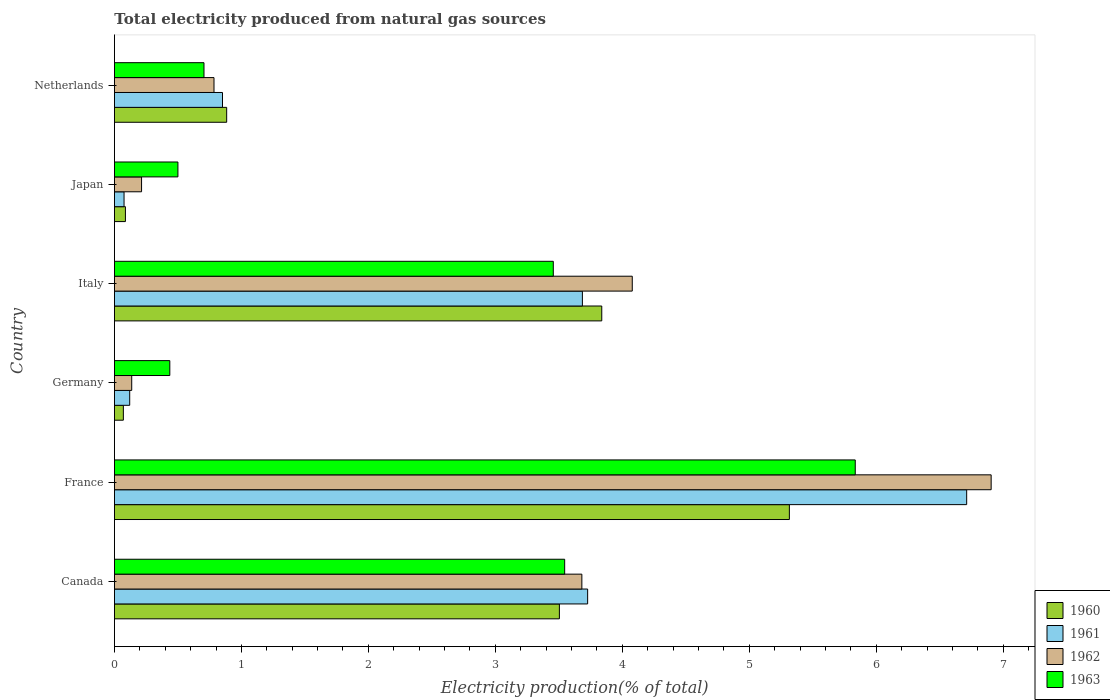How many different coloured bars are there?
Offer a terse response. 4. How many groups of bars are there?
Your response must be concise. 6. How many bars are there on the 4th tick from the bottom?
Give a very brief answer. 4. What is the label of the 4th group of bars from the top?
Ensure brevity in your answer.  Germany. What is the total electricity produced in 1960 in Germany?
Offer a very short reply. 0.07. Across all countries, what is the maximum total electricity produced in 1960?
Offer a terse response. 5.32. Across all countries, what is the minimum total electricity produced in 1961?
Your answer should be compact. 0.08. In which country was the total electricity produced in 1961 maximum?
Your answer should be very brief. France. What is the total total electricity produced in 1963 in the graph?
Give a very brief answer. 14.48. What is the difference between the total electricity produced in 1960 in France and that in Germany?
Keep it short and to the point. 5.25. What is the difference between the total electricity produced in 1961 in France and the total electricity produced in 1960 in Canada?
Your response must be concise. 3.21. What is the average total electricity produced in 1961 per country?
Make the answer very short. 2.53. What is the difference between the total electricity produced in 1962 and total electricity produced in 1963 in Germany?
Ensure brevity in your answer.  -0.3. What is the ratio of the total electricity produced in 1961 in France to that in Japan?
Provide a short and direct response. 88.67. Is the total electricity produced in 1961 in Canada less than that in Germany?
Give a very brief answer. No. What is the difference between the highest and the second highest total electricity produced in 1962?
Your response must be concise. 2.83. What is the difference between the highest and the lowest total electricity produced in 1962?
Offer a very short reply. 6.77. In how many countries, is the total electricity produced in 1961 greater than the average total electricity produced in 1961 taken over all countries?
Ensure brevity in your answer.  3. Is the sum of the total electricity produced in 1960 in Canada and Germany greater than the maximum total electricity produced in 1962 across all countries?
Your response must be concise. No. What does the 4th bar from the top in Japan represents?
Provide a succinct answer. 1960. What does the 1st bar from the bottom in Japan represents?
Ensure brevity in your answer.  1960. Are all the bars in the graph horizontal?
Provide a short and direct response. Yes. How many countries are there in the graph?
Make the answer very short. 6. Does the graph contain any zero values?
Give a very brief answer. No. Does the graph contain grids?
Ensure brevity in your answer.  No. Where does the legend appear in the graph?
Your response must be concise. Bottom right. How many legend labels are there?
Give a very brief answer. 4. How are the legend labels stacked?
Provide a succinct answer. Vertical. What is the title of the graph?
Your answer should be compact. Total electricity produced from natural gas sources. What is the label or title of the X-axis?
Your answer should be very brief. Electricity production(% of total). What is the label or title of the Y-axis?
Make the answer very short. Country. What is the Electricity production(% of total) of 1960 in Canada?
Your answer should be compact. 3.5. What is the Electricity production(% of total) of 1961 in Canada?
Keep it short and to the point. 3.73. What is the Electricity production(% of total) in 1962 in Canada?
Ensure brevity in your answer.  3.68. What is the Electricity production(% of total) of 1963 in Canada?
Give a very brief answer. 3.55. What is the Electricity production(% of total) of 1960 in France?
Offer a very short reply. 5.32. What is the Electricity production(% of total) in 1961 in France?
Your answer should be very brief. 6.71. What is the Electricity production(% of total) in 1962 in France?
Ensure brevity in your answer.  6.91. What is the Electricity production(% of total) of 1963 in France?
Your response must be concise. 5.83. What is the Electricity production(% of total) of 1960 in Germany?
Your response must be concise. 0.07. What is the Electricity production(% of total) in 1961 in Germany?
Provide a short and direct response. 0.12. What is the Electricity production(% of total) of 1962 in Germany?
Provide a succinct answer. 0.14. What is the Electricity production(% of total) in 1963 in Germany?
Your response must be concise. 0.44. What is the Electricity production(% of total) of 1960 in Italy?
Your answer should be very brief. 3.84. What is the Electricity production(% of total) of 1961 in Italy?
Your answer should be very brief. 3.69. What is the Electricity production(% of total) of 1962 in Italy?
Ensure brevity in your answer.  4.08. What is the Electricity production(% of total) of 1963 in Italy?
Offer a very short reply. 3.46. What is the Electricity production(% of total) in 1960 in Japan?
Your answer should be compact. 0.09. What is the Electricity production(% of total) of 1961 in Japan?
Your response must be concise. 0.08. What is the Electricity production(% of total) of 1962 in Japan?
Make the answer very short. 0.21. What is the Electricity production(% of total) in 1963 in Japan?
Provide a short and direct response. 0.5. What is the Electricity production(% of total) in 1960 in Netherlands?
Your response must be concise. 0.88. What is the Electricity production(% of total) in 1961 in Netherlands?
Your answer should be compact. 0.85. What is the Electricity production(% of total) in 1962 in Netherlands?
Your answer should be very brief. 0.78. What is the Electricity production(% of total) of 1963 in Netherlands?
Keep it short and to the point. 0.71. Across all countries, what is the maximum Electricity production(% of total) of 1960?
Your answer should be compact. 5.32. Across all countries, what is the maximum Electricity production(% of total) of 1961?
Offer a terse response. 6.71. Across all countries, what is the maximum Electricity production(% of total) of 1962?
Provide a succinct answer. 6.91. Across all countries, what is the maximum Electricity production(% of total) in 1963?
Ensure brevity in your answer.  5.83. Across all countries, what is the minimum Electricity production(% of total) in 1960?
Provide a short and direct response. 0.07. Across all countries, what is the minimum Electricity production(% of total) in 1961?
Offer a terse response. 0.08. Across all countries, what is the minimum Electricity production(% of total) in 1962?
Keep it short and to the point. 0.14. Across all countries, what is the minimum Electricity production(% of total) in 1963?
Your response must be concise. 0.44. What is the total Electricity production(% of total) of 1960 in the graph?
Offer a very short reply. 13.7. What is the total Electricity production(% of total) in 1961 in the graph?
Your answer should be very brief. 15.17. What is the total Electricity production(% of total) in 1962 in the graph?
Give a very brief answer. 15.8. What is the total Electricity production(% of total) in 1963 in the graph?
Provide a short and direct response. 14.48. What is the difference between the Electricity production(% of total) in 1960 in Canada and that in France?
Give a very brief answer. -1.81. What is the difference between the Electricity production(% of total) of 1961 in Canada and that in France?
Your answer should be compact. -2.99. What is the difference between the Electricity production(% of total) of 1962 in Canada and that in France?
Provide a succinct answer. -3.22. What is the difference between the Electricity production(% of total) in 1963 in Canada and that in France?
Your response must be concise. -2.29. What is the difference between the Electricity production(% of total) in 1960 in Canada and that in Germany?
Offer a very short reply. 3.43. What is the difference between the Electricity production(% of total) in 1961 in Canada and that in Germany?
Your answer should be compact. 3.61. What is the difference between the Electricity production(% of total) in 1962 in Canada and that in Germany?
Ensure brevity in your answer.  3.55. What is the difference between the Electricity production(% of total) of 1963 in Canada and that in Germany?
Your answer should be compact. 3.11. What is the difference between the Electricity production(% of total) in 1960 in Canada and that in Italy?
Give a very brief answer. -0.33. What is the difference between the Electricity production(% of total) of 1961 in Canada and that in Italy?
Give a very brief answer. 0.04. What is the difference between the Electricity production(% of total) in 1962 in Canada and that in Italy?
Your response must be concise. -0.4. What is the difference between the Electricity production(% of total) of 1963 in Canada and that in Italy?
Keep it short and to the point. 0.09. What is the difference between the Electricity production(% of total) in 1960 in Canada and that in Japan?
Keep it short and to the point. 3.42. What is the difference between the Electricity production(% of total) of 1961 in Canada and that in Japan?
Provide a short and direct response. 3.65. What is the difference between the Electricity production(% of total) of 1962 in Canada and that in Japan?
Give a very brief answer. 3.47. What is the difference between the Electricity production(% of total) of 1963 in Canada and that in Japan?
Your answer should be compact. 3.05. What is the difference between the Electricity production(% of total) of 1960 in Canada and that in Netherlands?
Give a very brief answer. 2.62. What is the difference between the Electricity production(% of total) in 1961 in Canada and that in Netherlands?
Offer a very short reply. 2.88. What is the difference between the Electricity production(% of total) in 1962 in Canada and that in Netherlands?
Your response must be concise. 2.9. What is the difference between the Electricity production(% of total) of 1963 in Canada and that in Netherlands?
Keep it short and to the point. 2.84. What is the difference between the Electricity production(% of total) in 1960 in France and that in Germany?
Offer a terse response. 5.25. What is the difference between the Electricity production(% of total) in 1961 in France and that in Germany?
Provide a succinct answer. 6.59. What is the difference between the Electricity production(% of total) in 1962 in France and that in Germany?
Make the answer very short. 6.77. What is the difference between the Electricity production(% of total) of 1963 in France and that in Germany?
Offer a terse response. 5.4. What is the difference between the Electricity production(% of total) of 1960 in France and that in Italy?
Keep it short and to the point. 1.48. What is the difference between the Electricity production(% of total) in 1961 in France and that in Italy?
Offer a terse response. 3.03. What is the difference between the Electricity production(% of total) of 1962 in France and that in Italy?
Provide a succinct answer. 2.83. What is the difference between the Electricity production(% of total) in 1963 in France and that in Italy?
Your answer should be compact. 2.38. What is the difference between the Electricity production(% of total) in 1960 in France and that in Japan?
Provide a short and direct response. 5.23. What is the difference between the Electricity production(% of total) in 1961 in France and that in Japan?
Your response must be concise. 6.64. What is the difference between the Electricity production(% of total) of 1962 in France and that in Japan?
Provide a short and direct response. 6.69. What is the difference between the Electricity production(% of total) of 1963 in France and that in Japan?
Offer a very short reply. 5.33. What is the difference between the Electricity production(% of total) of 1960 in France and that in Netherlands?
Your response must be concise. 4.43. What is the difference between the Electricity production(% of total) of 1961 in France and that in Netherlands?
Make the answer very short. 5.86. What is the difference between the Electricity production(% of total) in 1962 in France and that in Netherlands?
Offer a very short reply. 6.12. What is the difference between the Electricity production(% of total) in 1963 in France and that in Netherlands?
Provide a short and direct response. 5.13. What is the difference between the Electricity production(% of total) in 1960 in Germany and that in Italy?
Give a very brief answer. -3.77. What is the difference between the Electricity production(% of total) in 1961 in Germany and that in Italy?
Your response must be concise. -3.57. What is the difference between the Electricity production(% of total) in 1962 in Germany and that in Italy?
Keep it short and to the point. -3.94. What is the difference between the Electricity production(% of total) of 1963 in Germany and that in Italy?
Your response must be concise. -3.02. What is the difference between the Electricity production(% of total) in 1960 in Germany and that in Japan?
Offer a terse response. -0.02. What is the difference between the Electricity production(% of total) in 1961 in Germany and that in Japan?
Provide a succinct answer. 0.04. What is the difference between the Electricity production(% of total) in 1962 in Germany and that in Japan?
Your answer should be compact. -0.08. What is the difference between the Electricity production(% of total) of 1963 in Germany and that in Japan?
Ensure brevity in your answer.  -0.06. What is the difference between the Electricity production(% of total) in 1960 in Germany and that in Netherlands?
Keep it short and to the point. -0.81. What is the difference between the Electricity production(% of total) of 1961 in Germany and that in Netherlands?
Your response must be concise. -0.73. What is the difference between the Electricity production(% of total) of 1962 in Germany and that in Netherlands?
Your answer should be very brief. -0.65. What is the difference between the Electricity production(% of total) of 1963 in Germany and that in Netherlands?
Offer a very short reply. -0.27. What is the difference between the Electricity production(% of total) of 1960 in Italy and that in Japan?
Provide a short and direct response. 3.75. What is the difference between the Electricity production(% of total) in 1961 in Italy and that in Japan?
Give a very brief answer. 3.61. What is the difference between the Electricity production(% of total) of 1962 in Italy and that in Japan?
Ensure brevity in your answer.  3.86. What is the difference between the Electricity production(% of total) of 1963 in Italy and that in Japan?
Offer a terse response. 2.96. What is the difference between the Electricity production(% of total) in 1960 in Italy and that in Netherlands?
Your answer should be very brief. 2.95. What is the difference between the Electricity production(% of total) of 1961 in Italy and that in Netherlands?
Give a very brief answer. 2.83. What is the difference between the Electricity production(% of total) in 1962 in Italy and that in Netherlands?
Offer a very short reply. 3.29. What is the difference between the Electricity production(% of total) in 1963 in Italy and that in Netherlands?
Provide a short and direct response. 2.75. What is the difference between the Electricity production(% of total) in 1960 in Japan and that in Netherlands?
Ensure brevity in your answer.  -0.8. What is the difference between the Electricity production(% of total) in 1961 in Japan and that in Netherlands?
Provide a short and direct response. -0.78. What is the difference between the Electricity production(% of total) of 1962 in Japan and that in Netherlands?
Give a very brief answer. -0.57. What is the difference between the Electricity production(% of total) of 1963 in Japan and that in Netherlands?
Your answer should be very brief. -0.21. What is the difference between the Electricity production(% of total) in 1960 in Canada and the Electricity production(% of total) in 1961 in France?
Ensure brevity in your answer.  -3.21. What is the difference between the Electricity production(% of total) in 1960 in Canada and the Electricity production(% of total) in 1962 in France?
Ensure brevity in your answer.  -3.4. What is the difference between the Electricity production(% of total) of 1960 in Canada and the Electricity production(% of total) of 1963 in France?
Provide a short and direct response. -2.33. What is the difference between the Electricity production(% of total) of 1961 in Canada and the Electricity production(% of total) of 1962 in France?
Your answer should be compact. -3.18. What is the difference between the Electricity production(% of total) in 1961 in Canada and the Electricity production(% of total) in 1963 in France?
Offer a terse response. -2.11. What is the difference between the Electricity production(% of total) of 1962 in Canada and the Electricity production(% of total) of 1963 in France?
Offer a terse response. -2.15. What is the difference between the Electricity production(% of total) in 1960 in Canada and the Electricity production(% of total) in 1961 in Germany?
Give a very brief answer. 3.38. What is the difference between the Electricity production(% of total) of 1960 in Canada and the Electricity production(% of total) of 1962 in Germany?
Provide a short and direct response. 3.37. What is the difference between the Electricity production(% of total) in 1960 in Canada and the Electricity production(% of total) in 1963 in Germany?
Provide a short and direct response. 3.07. What is the difference between the Electricity production(% of total) in 1961 in Canada and the Electricity production(% of total) in 1962 in Germany?
Give a very brief answer. 3.59. What is the difference between the Electricity production(% of total) in 1961 in Canada and the Electricity production(% of total) in 1963 in Germany?
Your answer should be compact. 3.29. What is the difference between the Electricity production(% of total) in 1962 in Canada and the Electricity production(% of total) in 1963 in Germany?
Offer a terse response. 3.25. What is the difference between the Electricity production(% of total) of 1960 in Canada and the Electricity production(% of total) of 1961 in Italy?
Provide a short and direct response. -0.18. What is the difference between the Electricity production(% of total) in 1960 in Canada and the Electricity production(% of total) in 1962 in Italy?
Your response must be concise. -0.57. What is the difference between the Electricity production(% of total) in 1960 in Canada and the Electricity production(% of total) in 1963 in Italy?
Give a very brief answer. 0.05. What is the difference between the Electricity production(% of total) in 1961 in Canada and the Electricity production(% of total) in 1962 in Italy?
Offer a very short reply. -0.35. What is the difference between the Electricity production(% of total) in 1961 in Canada and the Electricity production(% of total) in 1963 in Italy?
Offer a very short reply. 0.27. What is the difference between the Electricity production(% of total) in 1962 in Canada and the Electricity production(% of total) in 1963 in Italy?
Provide a short and direct response. 0.23. What is the difference between the Electricity production(% of total) in 1960 in Canada and the Electricity production(% of total) in 1961 in Japan?
Give a very brief answer. 3.43. What is the difference between the Electricity production(% of total) of 1960 in Canada and the Electricity production(% of total) of 1962 in Japan?
Offer a terse response. 3.29. What is the difference between the Electricity production(% of total) of 1960 in Canada and the Electricity production(% of total) of 1963 in Japan?
Ensure brevity in your answer.  3. What is the difference between the Electricity production(% of total) of 1961 in Canada and the Electricity production(% of total) of 1962 in Japan?
Give a very brief answer. 3.51. What is the difference between the Electricity production(% of total) of 1961 in Canada and the Electricity production(% of total) of 1963 in Japan?
Offer a terse response. 3.23. What is the difference between the Electricity production(% of total) in 1962 in Canada and the Electricity production(% of total) in 1963 in Japan?
Offer a terse response. 3.18. What is the difference between the Electricity production(% of total) of 1960 in Canada and the Electricity production(% of total) of 1961 in Netherlands?
Your answer should be very brief. 2.65. What is the difference between the Electricity production(% of total) in 1960 in Canada and the Electricity production(% of total) in 1962 in Netherlands?
Keep it short and to the point. 2.72. What is the difference between the Electricity production(% of total) of 1960 in Canada and the Electricity production(% of total) of 1963 in Netherlands?
Your answer should be very brief. 2.8. What is the difference between the Electricity production(% of total) of 1961 in Canada and the Electricity production(% of total) of 1962 in Netherlands?
Your response must be concise. 2.94. What is the difference between the Electricity production(% of total) in 1961 in Canada and the Electricity production(% of total) in 1963 in Netherlands?
Your answer should be compact. 3.02. What is the difference between the Electricity production(% of total) in 1962 in Canada and the Electricity production(% of total) in 1963 in Netherlands?
Make the answer very short. 2.98. What is the difference between the Electricity production(% of total) of 1960 in France and the Electricity production(% of total) of 1961 in Germany?
Provide a succinct answer. 5.2. What is the difference between the Electricity production(% of total) of 1960 in France and the Electricity production(% of total) of 1962 in Germany?
Your response must be concise. 5.18. What is the difference between the Electricity production(% of total) in 1960 in France and the Electricity production(% of total) in 1963 in Germany?
Ensure brevity in your answer.  4.88. What is the difference between the Electricity production(% of total) of 1961 in France and the Electricity production(% of total) of 1962 in Germany?
Ensure brevity in your answer.  6.58. What is the difference between the Electricity production(% of total) of 1961 in France and the Electricity production(% of total) of 1963 in Germany?
Offer a very short reply. 6.28. What is the difference between the Electricity production(% of total) of 1962 in France and the Electricity production(% of total) of 1963 in Germany?
Give a very brief answer. 6.47. What is the difference between the Electricity production(% of total) in 1960 in France and the Electricity production(% of total) in 1961 in Italy?
Offer a very short reply. 1.63. What is the difference between the Electricity production(% of total) of 1960 in France and the Electricity production(% of total) of 1962 in Italy?
Give a very brief answer. 1.24. What is the difference between the Electricity production(% of total) in 1960 in France and the Electricity production(% of total) in 1963 in Italy?
Keep it short and to the point. 1.86. What is the difference between the Electricity production(% of total) in 1961 in France and the Electricity production(% of total) in 1962 in Italy?
Ensure brevity in your answer.  2.63. What is the difference between the Electricity production(% of total) of 1961 in France and the Electricity production(% of total) of 1963 in Italy?
Ensure brevity in your answer.  3.26. What is the difference between the Electricity production(% of total) in 1962 in France and the Electricity production(% of total) in 1963 in Italy?
Make the answer very short. 3.45. What is the difference between the Electricity production(% of total) of 1960 in France and the Electricity production(% of total) of 1961 in Japan?
Offer a very short reply. 5.24. What is the difference between the Electricity production(% of total) in 1960 in France and the Electricity production(% of total) in 1962 in Japan?
Offer a terse response. 5.1. What is the difference between the Electricity production(% of total) in 1960 in France and the Electricity production(% of total) in 1963 in Japan?
Provide a short and direct response. 4.82. What is the difference between the Electricity production(% of total) of 1961 in France and the Electricity production(% of total) of 1962 in Japan?
Provide a short and direct response. 6.5. What is the difference between the Electricity production(% of total) in 1961 in France and the Electricity production(% of total) in 1963 in Japan?
Provide a succinct answer. 6.21. What is the difference between the Electricity production(% of total) in 1962 in France and the Electricity production(% of total) in 1963 in Japan?
Keep it short and to the point. 6.4. What is the difference between the Electricity production(% of total) in 1960 in France and the Electricity production(% of total) in 1961 in Netherlands?
Your answer should be compact. 4.46. What is the difference between the Electricity production(% of total) in 1960 in France and the Electricity production(% of total) in 1962 in Netherlands?
Make the answer very short. 4.53. What is the difference between the Electricity production(% of total) in 1960 in France and the Electricity production(% of total) in 1963 in Netherlands?
Your answer should be very brief. 4.61. What is the difference between the Electricity production(% of total) of 1961 in France and the Electricity production(% of total) of 1962 in Netherlands?
Keep it short and to the point. 5.93. What is the difference between the Electricity production(% of total) of 1961 in France and the Electricity production(% of total) of 1963 in Netherlands?
Ensure brevity in your answer.  6.01. What is the difference between the Electricity production(% of total) in 1962 in France and the Electricity production(% of total) in 1963 in Netherlands?
Give a very brief answer. 6.2. What is the difference between the Electricity production(% of total) in 1960 in Germany and the Electricity production(% of total) in 1961 in Italy?
Your answer should be compact. -3.62. What is the difference between the Electricity production(% of total) of 1960 in Germany and the Electricity production(% of total) of 1962 in Italy?
Offer a terse response. -4.01. What is the difference between the Electricity production(% of total) in 1960 in Germany and the Electricity production(% of total) in 1963 in Italy?
Your answer should be very brief. -3.39. What is the difference between the Electricity production(% of total) in 1961 in Germany and the Electricity production(% of total) in 1962 in Italy?
Your response must be concise. -3.96. What is the difference between the Electricity production(% of total) of 1961 in Germany and the Electricity production(% of total) of 1963 in Italy?
Keep it short and to the point. -3.34. What is the difference between the Electricity production(% of total) of 1962 in Germany and the Electricity production(% of total) of 1963 in Italy?
Your response must be concise. -3.32. What is the difference between the Electricity production(% of total) in 1960 in Germany and the Electricity production(% of total) in 1961 in Japan?
Ensure brevity in your answer.  -0.01. What is the difference between the Electricity production(% of total) in 1960 in Germany and the Electricity production(% of total) in 1962 in Japan?
Ensure brevity in your answer.  -0.14. What is the difference between the Electricity production(% of total) of 1960 in Germany and the Electricity production(% of total) of 1963 in Japan?
Make the answer very short. -0.43. What is the difference between the Electricity production(% of total) of 1961 in Germany and the Electricity production(% of total) of 1962 in Japan?
Offer a terse response. -0.09. What is the difference between the Electricity production(% of total) of 1961 in Germany and the Electricity production(% of total) of 1963 in Japan?
Offer a very short reply. -0.38. What is the difference between the Electricity production(% of total) of 1962 in Germany and the Electricity production(% of total) of 1963 in Japan?
Your answer should be very brief. -0.36. What is the difference between the Electricity production(% of total) of 1960 in Germany and the Electricity production(% of total) of 1961 in Netherlands?
Keep it short and to the point. -0.78. What is the difference between the Electricity production(% of total) in 1960 in Germany and the Electricity production(% of total) in 1962 in Netherlands?
Offer a terse response. -0.71. What is the difference between the Electricity production(% of total) of 1960 in Germany and the Electricity production(% of total) of 1963 in Netherlands?
Ensure brevity in your answer.  -0.64. What is the difference between the Electricity production(% of total) in 1961 in Germany and the Electricity production(% of total) in 1962 in Netherlands?
Your answer should be compact. -0.66. What is the difference between the Electricity production(% of total) of 1961 in Germany and the Electricity production(% of total) of 1963 in Netherlands?
Offer a very short reply. -0.58. What is the difference between the Electricity production(% of total) of 1962 in Germany and the Electricity production(% of total) of 1963 in Netherlands?
Give a very brief answer. -0.57. What is the difference between the Electricity production(% of total) of 1960 in Italy and the Electricity production(% of total) of 1961 in Japan?
Your response must be concise. 3.76. What is the difference between the Electricity production(% of total) of 1960 in Italy and the Electricity production(% of total) of 1962 in Japan?
Ensure brevity in your answer.  3.62. What is the difference between the Electricity production(% of total) of 1960 in Italy and the Electricity production(% of total) of 1963 in Japan?
Provide a short and direct response. 3.34. What is the difference between the Electricity production(% of total) of 1961 in Italy and the Electricity production(% of total) of 1962 in Japan?
Keep it short and to the point. 3.47. What is the difference between the Electricity production(% of total) of 1961 in Italy and the Electricity production(% of total) of 1963 in Japan?
Ensure brevity in your answer.  3.19. What is the difference between the Electricity production(% of total) in 1962 in Italy and the Electricity production(% of total) in 1963 in Japan?
Ensure brevity in your answer.  3.58. What is the difference between the Electricity production(% of total) of 1960 in Italy and the Electricity production(% of total) of 1961 in Netherlands?
Offer a very short reply. 2.99. What is the difference between the Electricity production(% of total) of 1960 in Italy and the Electricity production(% of total) of 1962 in Netherlands?
Keep it short and to the point. 3.05. What is the difference between the Electricity production(% of total) in 1960 in Italy and the Electricity production(% of total) in 1963 in Netherlands?
Provide a short and direct response. 3.13. What is the difference between the Electricity production(% of total) in 1961 in Italy and the Electricity production(% of total) in 1962 in Netherlands?
Your answer should be very brief. 2.9. What is the difference between the Electricity production(% of total) of 1961 in Italy and the Electricity production(% of total) of 1963 in Netherlands?
Give a very brief answer. 2.98. What is the difference between the Electricity production(% of total) of 1962 in Italy and the Electricity production(% of total) of 1963 in Netherlands?
Your answer should be very brief. 3.37. What is the difference between the Electricity production(% of total) of 1960 in Japan and the Electricity production(% of total) of 1961 in Netherlands?
Give a very brief answer. -0.76. What is the difference between the Electricity production(% of total) of 1960 in Japan and the Electricity production(% of total) of 1962 in Netherlands?
Provide a short and direct response. -0.7. What is the difference between the Electricity production(% of total) of 1960 in Japan and the Electricity production(% of total) of 1963 in Netherlands?
Offer a terse response. -0.62. What is the difference between the Electricity production(% of total) of 1961 in Japan and the Electricity production(% of total) of 1962 in Netherlands?
Give a very brief answer. -0.71. What is the difference between the Electricity production(% of total) in 1961 in Japan and the Electricity production(% of total) in 1963 in Netherlands?
Your answer should be very brief. -0.63. What is the difference between the Electricity production(% of total) of 1962 in Japan and the Electricity production(% of total) of 1963 in Netherlands?
Your answer should be very brief. -0.49. What is the average Electricity production(% of total) in 1960 per country?
Keep it short and to the point. 2.28. What is the average Electricity production(% of total) in 1961 per country?
Make the answer very short. 2.53. What is the average Electricity production(% of total) in 1962 per country?
Keep it short and to the point. 2.63. What is the average Electricity production(% of total) of 1963 per country?
Offer a terse response. 2.41. What is the difference between the Electricity production(% of total) in 1960 and Electricity production(% of total) in 1961 in Canada?
Make the answer very short. -0.22. What is the difference between the Electricity production(% of total) in 1960 and Electricity production(% of total) in 1962 in Canada?
Offer a very short reply. -0.18. What is the difference between the Electricity production(% of total) in 1960 and Electricity production(% of total) in 1963 in Canada?
Give a very brief answer. -0.04. What is the difference between the Electricity production(% of total) of 1961 and Electricity production(% of total) of 1962 in Canada?
Your answer should be compact. 0.05. What is the difference between the Electricity production(% of total) in 1961 and Electricity production(% of total) in 1963 in Canada?
Ensure brevity in your answer.  0.18. What is the difference between the Electricity production(% of total) in 1962 and Electricity production(% of total) in 1963 in Canada?
Your answer should be very brief. 0.14. What is the difference between the Electricity production(% of total) in 1960 and Electricity production(% of total) in 1961 in France?
Provide a short and direct response. -1.4. What is the difference between the Electricity production(% of total) of 1960 and Electricity production(% of total) of 1962 in France?
Your answer should be compact. -1.59. What is the difference between the Electricity production(% of total) of 1960 and Electricity production(% of total) of 1963 in France?
Your answer should be very brief. -0.52. What is the difference between the Electricity production(% of total) in 1961 and Electricity production(% of total) in 1962 in France?
Offer a very short reply. -0.19. What is the difference between the Electricity production(% of total) of 1961 and Electricity production(% of total) of 1963 in France?
Provide a succinct answer. 0.88. What is the difference between the Electricity production(% of total) in 1962 and Electricity production(% of total) in 1963 in France?
Ensure brevity in your answer.  1.07. What is the difference between the Electricity production(% of total) in 1960 and Electricity production(% of total) in 1962 in Germany?
Provide a short and direct response. -0.07. What is the difference between the Electricity production(% of total) of 1960 and Electricity production(% of total) of 1963 in Germany?
Offer a very short reply. -0.37. What is the difference between the Electricity production(% of total) in 1961 and Electricity production(% of total) in 1962 in Germany?
Keep it short and to the point. -0.02. What is the difference between the Electricity production(% of total) in 1961 and Electricity production(% of total) in 1963 in Germany?
Keep it short and to the point. -0.32. What is the difference between the Electricity production(% of total) in 1962 and Electricity production(% of total) in 1963 in Germany?
Make the answer very short. -0.3. What is the difference between the Electricity production(% of total) in 1960 and Electricity production(% of total) in 1961 in Italy?
Your response must be concise. 0.15. What is the difference between the Electricity production(% of total) of 1960 and Electricity production(% of total) of 1962 in Italy?
Offer a terse response. -0.24. What is the difference between the Electricity production(% of total) in 1960 and Electricity production(% of total) in 1963 in Italy?
Ensure brevity in your answer.  0.38. What is the difference between the Electricity production(% of total) of 1961 and Electricity production(% of total) of 1962 in Italy?
Your answer should be compact. -0.39. What is the difference between the Electricity production(% of total) in 1961 and Electricity production(% of total) in 1963 in Italy?
Your response must be concise. 0.23. What is the difference between the Electricity production(% of total) in 1962 and Electricity production(% of total) in 1963 in Italy?
Make the answer very short. 0.62. What is the difference between the Electricity production(% of total) of 1960 and Electricity production(% of total) of 1961 in Japan?
Your response must be concise. 0.01. What is the difference between the Electricity production(% of total) of 1960 and Electricity production(% of total) of 1962 in Japan?
Offer a terse response. -0.13. What is the difference between the Electricity production(% of total) of 1960 and Electricity production(% of total) of 1963 in Japan?
Ensure brevity in your answer.  -0.41. What is the difference between the Electricity production(% of total) of 1961 and Electricity production(% of total) of 1962 in Japan?
Provide a succinct answer. -0.14. What is the difference between the Electricity production(% of total) in 1961 and Electricity production(% of total) in 1963 in Japan?
Keep it short and to the point. -0.42. What is the difference between the Electricity production(% of total) of 1962 and Electricity production(% of total) of 1963 in Japan?
Offer a very short reply. -0.29. What is the difference between the Electricity production(% of total) of 1960 and Electricity production(% of total) of 1961 in Netherlands?
Provide a succinct answer. 0.03. What is the difference between the Electricity production(% of total) in 1960 and Electricity production(% of total) in 1962 in Netherlands?
Make the answer very short. 0.1. What is the difference between the Electricity production(% of total) in 1960 and Electricity production(% of total) in 1963 in Netherlands?
Provide a short and direct response. 0.18. What is the difference between the Electricity production(% of total) in 1961 and Electricity production(% of total) in 1962 in Netherlands?
Offer a terse response. 0.07. What is the difference between the Electricity production(% of total) of 1961 and Electricity production(% of total) of 1963 in Netherlands?
Provide a short and direct response. 0.15. What is the difference between the Electricity production(% of total) of 1962 and Electricity production(% of total) of 1963 in Netherlands?
Keep it short and to the point. 0.08. What is the ratio of the Electricity production(% of total) in 1960 in Canada to that in France?
Offer a very short reply. 0.66. What is the ratio of the Electricity production(% of total) of 1961 in Canada to that in France?
Your answer should be compact. 0.56. What is the ratio of the Electricity production(% of total) in 1962 in Canada to that in France?
Provide a short and direct response. 0.53. What is the ratio of the Electricity production(% of total) in 1963 in Canada to that in France?
Provide a succinct answer. 0.61. What is the ratio of the Electricity production(% of total) in 1960 in Canada to that in Germany?
Make the answer very short. 49.85. What is the ratio of the Electricity production(% of total) of 1961 in Canada to that in Germany?
Provide a short and direct response. 30.98. What is the ratio of the Electricity production(% of total) of 1962 in Canada to that in Germany?
Make the answer very short. 27.02. What is the ratio of the Electricity production(% of total) of 1963 in Canada to that in Germany?
Offer a very short reply. 8.13. What is the ratio of the Electricity production(% of total) in 1960 in Canada to that in Italy?
Offer a very short reply. 0.91. What is the ratio of the Electricity production(% of total) in 1961 in Canada to that in Italy?
Provide a succinct answer. 1.01. What is the ratio of the Electricity production(% of total) in 1962 in Canada to that in Italy?
Your response must be concise. 0.9. What is the ratio of the Electricity production(% of total) of 1963 in Canada to that in Italy?
Your answer should be very brief. 1.03. What is the ratio of the Electricity production(% of total) in 1960 in Canada to that in Japan?
Keep it short and to the point. 40.48. What is the ratio of the Electricity production(% of total) in 1961 in Canada to that in Japan?
Keep it short and to the point. 49.23. What is the ratio of the Electricity production(% of total) of 1962 in Canada to that in Japan?
Offer a terse response. 17.23. What is the ratio of the Electricity production(% of total) of 1963 in Canada to that in Japan?
Keep it short and to the point. 7.09. What is the ratio of the Electricity production(% of total) of 1960 in Canada to that in Netherlands?
Offer a terse response. 3.96. What is the ratio of the Electricity production(% of total) in 1961 in Canada to that in Netherlands?
Your answer should be very brief. 4.38. What is the ratio of the Electricity production(% of total) of 1962 in Canada to that in Netherlands?
Your answer should be very brief. 4.69. What is the ratio of the Electricity production(% of total) in 1963 in Canada to that in Netherlands?
Your answer should be compact. 5.03. What is the ratio of the Electricity production(% of total) of 1960 in France to that in Germany?
Provide a short and direct response. 75.62. What is the ratio of the Electricity production(% of total) of 1961 in France to that in Germany?
Make the answer very short. 55.79. What is the ratio of the Electricity production(% of total) of 1962 in France to that in Germany?
Provide a succinct answer. 50.69. What is the ratio of the Electricity production(% of total) in 1963 in France to that in Germany?
Provide a succinct answer. 13.38. What is the ratio of the Electricity production(% of total) of 1960 in France to that in Italy?
Offer a very short reply. 1.39. What is the ratio of the Electricity production(% of total) of 1961 in France to that in Italy?
Keep it short and to the point. 1.82. What is the ratio of the Electricity production(% of total) of 1962 in France to that in Italy?
Your response must be concise. 1.69. What is the ratio of the Electricity production(% of total) of 1963 in France to that in Italy?
Offer a terse response. 1.69. What is the ratio of the Electricity production(% of total) in 1960 in France to that in Japan?
Keep it short and to the point. 61.4. What is the ratio of the Electricity production(% of total) in 1961 in France to that in Japan?
Offer a terse response. 88.67. What is the ratio of the Electricity production(% of total) of 1962 in France to that in Japan?
Your answer should be very brief. 32.32. What is the ratio of the Electricity production(% of total) in 1963 in France to that in Japan?
Your answer should be compact. 11.67. What is the ratio of the Electricity production(% of total) of 1960 in France to that in Netherlands?
Give a very brief answer. 6.01. What is the ratio of the Electricity production(% of total) in 1961 in France to that in Netherlands?
Keep it short and to the point. 7.89. What is the ratio of the Electricity production(% of total) of 1962 in France to that in Netherlands?
Keep it short and to the point. 8.8. What is the ratio of the Electricity production(% of total) of 1963 in France to that in Netherlands?
Offer a terse response. 8.27. What is the ratio of the Electricity production(% of total) in 1960 in Germany to that in Italy?
Keep it short and to the point. 0.02. What is the ratio of the Electricity production(% of total) of 1961 in Germany to that in Italy?
Provide a short and direct response. 0.03. What is the ratio of the Electricity production(% of total) in 1962 in Germany to that in Italy?
Make the answer very short. 0.03. What is the ratio of the Electricity production(% of total) in 1963 in Germany to that in Italy?
Provide a short and direct response. 0.13. What is the ratio of the Electricity production(% of total) of 1960 in Germany to that in Japan?
Offer a very short reply. 0.81. What is the ratio of the Electricity production(% of total) of 1961 in Germany to that in Japan?
Keep it short and to the point. 1.59. What is the ratio of the Electricity production(% of total) of 1962 in Germany to that in Japan?
Give a very brief answer. 0.64. What is the ratio of the Electricity production(% of total) in 1963 in Germany to that in Japan?
Make the answer very short. 0.87. What is the ratio of the Electricity production(% of total) in 1960 in Germany to that in Netherlands?
Make the answer very short. 0.08. What is the ratio of the Electricity production(% of total) in 1961 in Germany to that in Netherlands?
Ensure brevity in your answer.  0.14. What is the ratio of the Electricity production(% of total) of 1962 in Germany to that in Netherlands?
Provide a succinct answer. 0.17. What is the ratio of the Electricity production(% of total) of 1963 in Germany to that in Netherlands?
Your answer should be compact. 0.62. What is the ratio of the Electricity production(% of total) in 1960 in Italy to that in Japan?
Provide a short and direct response. 44.33. What is the ratio of the Electricity production(% of total) in 1961 in Italy to that in Japan?
Offer a very short reply. 48.69. What is the ratio of the Electricity production(% of total) of 1962 in Italy to that in Japan?
Your answer should be compact. 19.09. What is the ratio of the Electricity production(% of total) of 1963 in Italy to that in Japan?
Keep it short and to the point. 6.91. What is the ratio of the Electricity production(% of total) in 1960 in Italy to that in Netherlands?
Offer a terse response. 4.34. What is the ratio of the Electricity production(% of total) in 1961 in Italy to that in Netherlands?
Offer a terse response. 4.33. What is the ratio of the Electricity production(% of total) in 1962 in Italy to that in Netherlands?
Offer a very short reply. 5.2. What is the ratio of the Electricity production(% of total) of 1963 in Italy to that in Netherlands?
Your response must be concise. 4.9. What is the ratio of the Electricity production(% of total) in 1960 in Japan to that in Netherlands?
Give a very brief answer. 0.1. What is the ratio of the Electricity production(% of total) of 1961 in Japan to that in Netherlands?
Provide a succinct answer. 0.09. What is the ratio of the Electricity production(% of total) of 1962 in Japan to that in Netherlands?
Give a very brief answer. 0.27. What is the ratio of the Electricity production(% of total) of 1963 in Japan to that in Netherlands?
Provide a succinct answer. 0.71. What is the difference between the highest and the second highest Electricity production(% of total) of 1960?
Your answer should be very brief. 1.48. What is the difference between the highest and the second highest Electricity production(% of total) in 1961?
Offer a very short reply. 2.99. What is the difference between the highest and the second highest Electricity production(% of total) of 1962?
Keep it short and to the point. 2.83. What is the difference between the highest and the second highest Electricity production(% of total) of 1963?
Your answer should be very brief. 2.29. What is the difference between the highest and the lowest Electricity production(% of total) of 1960?
Offer a very short reply. 5.25. What is the difference between the highest and the lowest Electricity production(% of total) of 1961?
Offer a very short reply. 6.64. What is the difference between the highest and the lowest Electricity production(% of total) of 1962?
Your answer should be very brief. 6.77. What is the difference between the highest and the lowest Electricity production(% of total) of 1963?
Ensure brevity in your answer.  5.4. 